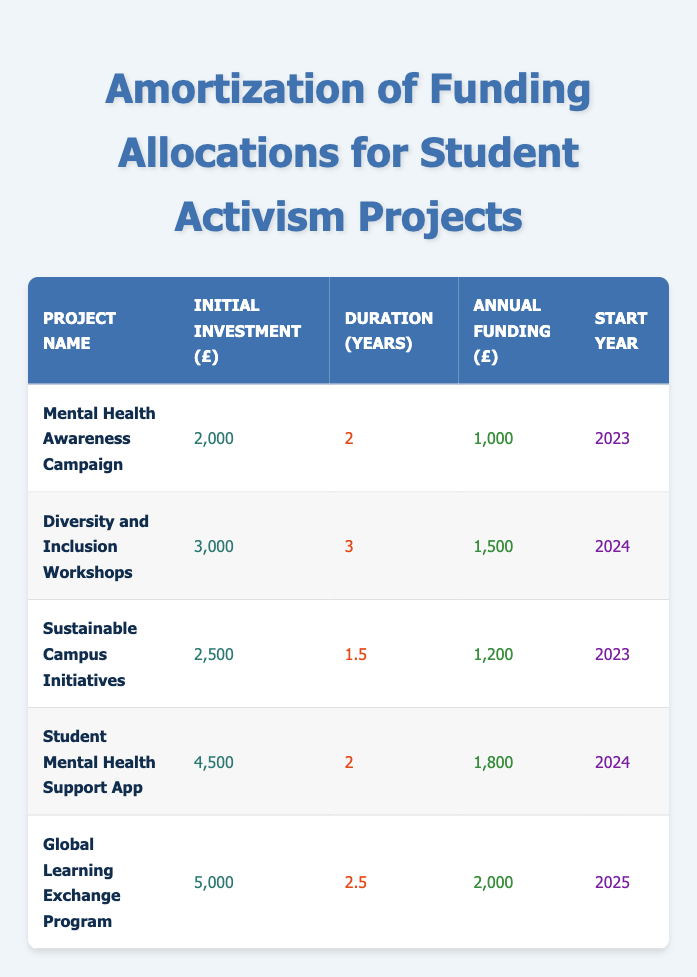What is the initial investment for the Mental Health Awareness Campaign? The table shows that the initial investment for the Mental Health Awareness Campaign is 2,000 pounds.
Answer: 2,000 How many projects have an annual funding of more than 1,500 pounds? From the table, we can see that the projects with annual funding greater than 1,500 pounds are: Diversity and Inclusion Workshops (1,500), Student Mental Health Support App (1,800), and Global Learning Exchange Program (2,000). There are three projects that meet this criteria.
Answer: 3 What is the total initial investment for all projects? To find the total initial investment, we sum the initial investments of each project: 2,000 + 3,000 + 2,500 + 4,500 + 5,000 = 17,000 pounds.
Answer: 17,000 Is there any project that has a duration of 1.5 years? Looking at the table, we can see that the Sustainable Campus Initiatives has a duration of 1.5 years. Therefore, the answer is yes.
Answer: Yes Which project starts in 2025 and what is its annual funding amount? The Global Learning Exchange Program starts in 2025, and its annual funding amount is 2,000 pounds as shown in the table.
Answer: Global Learning Exchange Program, 2,000 What is the average duration of all projects? To find the average duration, we first sum the durations: 2 + 3 + 1.5 + 2 + 2.5 = 11 years. Then, we divide by the number of projects (5): 11 / 5 = 2.2 years.
Answer: 2.2 How much total funding will be allocated for the Student Mental Health Support App over its duration? The total funding allocation is calculated by multiplying the annual funding (1,800 pounds) by the duration (2 years): 1,800 * 2 = 3,600 pounds.
Answer: 3,600 Which project has the highest initial investment and what is the amount? The table lists the projects, and the one with the highest initial investment is the Global Learning Exchange Program at 5,000 pounds.
Answer: Global Learning Exchange Program, 5,000 Are there any projects that have both an initial investment and annual funding over 3,000 pounds? In the table, the Diversity and Inclusion Workshops have an initial investment of 3,000 pounds and an annual funding of 1,500 pounds, and the Global Learning Exchange Program has an initial investment of 5,000 pounds and annual funding of 2,000 pounds. No project exceeds both criteria.
Answer: No 